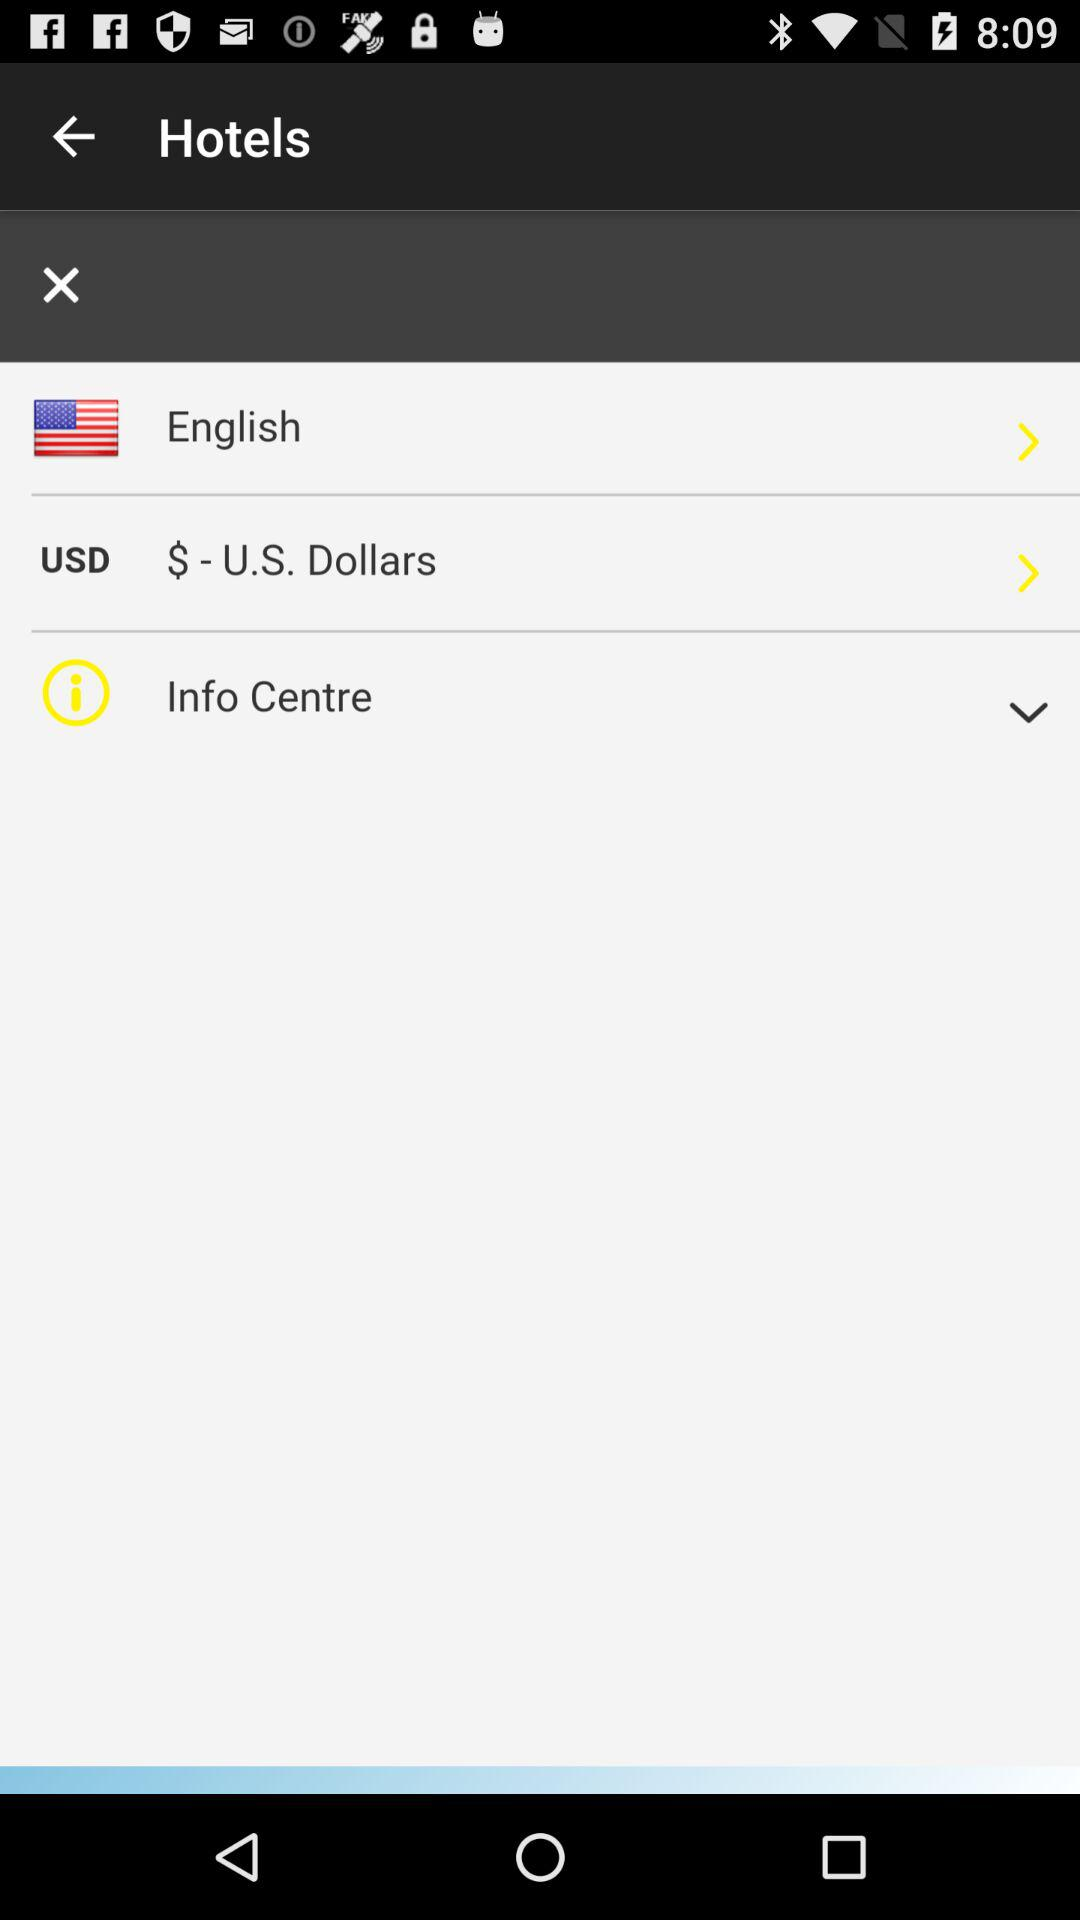What currency is being selected in the interface? The currency selected in the interface is USD, represented by the symbol '$' - U.S. Dollars, which is clearly seen highlighted under currency options. 